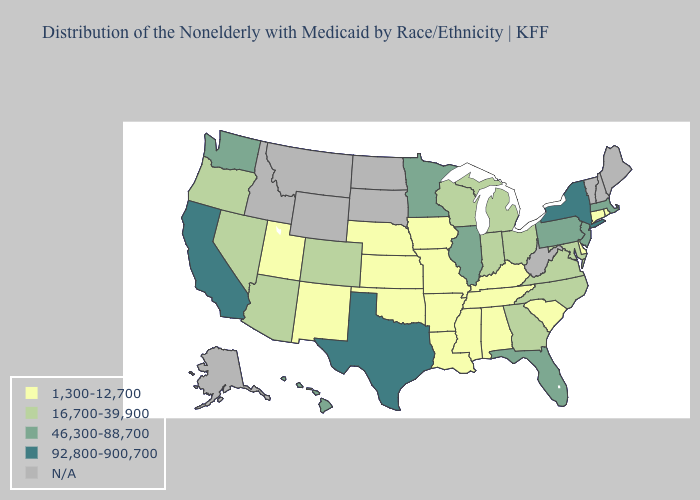Name the states that have a value in the range N/A?
Short answer required. Alaska, Idaho, Maine, Montana, New Hampshire, North Dakota, South Dakota, Vermont, West Virginia, Wyoming. What is the highest value in the Northeast ?
Be succinct. 92,800-900,700. Name the states that have a value in the range 92,800-900,700?
Quick response, please. California, New York, Texas. Which states have the lowest value in the West?
Concise answer only. New Mexico, Utah. What is the value of Mississippi?
Write a very short answer. 1,300-12,700. Among the states that border Ohio , which have the lowest value?
Keep it brief. Kentucky. Does South Carolina have the lowest value in the South?
Short answer required. Yes. Which states have the highest value in the USA?
Be succinct. California, New York, Texas. What is the value of Washington?
Give a very brief answer. 46,300-88,700. Does Minnesota have the highest value in the MidWest?
Be succinct. Yes. How many symbols are there in the legend?
Quick response, please. 5. What is the highest value in the USA?
Short answer required. 92,800-900,700. Does Maryland have the lowest value in the USA?
Answer briefly. No. What is the lowest value in the MidWest?
Concise answer only. 1,300-12,700. Name the states that have a value in the range 1,300-12,700?
Keep it brief. Alabama, Arkansas, Connecticut, Delaware, Iowa, Kansas, Kentucky, Louisiana, Mississippi, Missouri, Nebraska, New Mexico, Oklahoma, Rhode Island, South Carolina, Tennessee, Utah. 